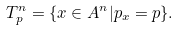<formula> <loc_0><loc_0><loc_500><loc_500>T _ { p } ^ { n } = \{ x \in A ^ { n } | p _ { x } = p \} .</formula> 